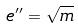Convert formula to latex. <formula><loc_0><loc_0><loc_500><loc_500>e ^ { \prime \prime } = \sqrt { m }</formula> 